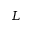Convert formula to latex. <formula><loc_0><loc_0><loc_500><loc_500>L</formula> 